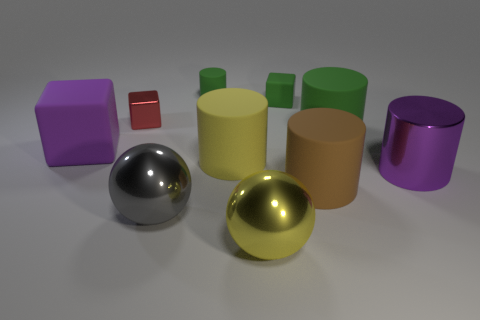What material is the cylinder that is the same color as the large cube?
Keep it short and to the point. Metal. What number of red objects are made of the same material as the big gray ball?
Offer a very short reply. 1. There is a matte block right of the small red shiny block; does it have the same color as the small cylinder?
Ensure brevity in your answer.  Yes. How many red things are small cubes or tiny cylinders?
Your answer should be very brief. 1. Is there anything else that is the same material as the large brown cylinder?
Your answer should be compact. Yes. Does the purple object behind the big purple cylinder have the same material as the tiny red block?
Your response must be concise. No. What number of things are small green matte things or matte things behind the brown matte cylinder?
Your answer should be very brief. 5. How many large purple metal objects are left of the large metallic ball in front of the metallic ball behind the yellow metallic thing?
Give a very brief answer. 0. There is a big purple thing that is behind the large purple metal cylinder; does it have the same shape as the large purple metal object?
Ensure brevity in your answer.  No. Are there any red metal cubes behind the cube that is behind the small red object?
Provide a short and direct response. No. 